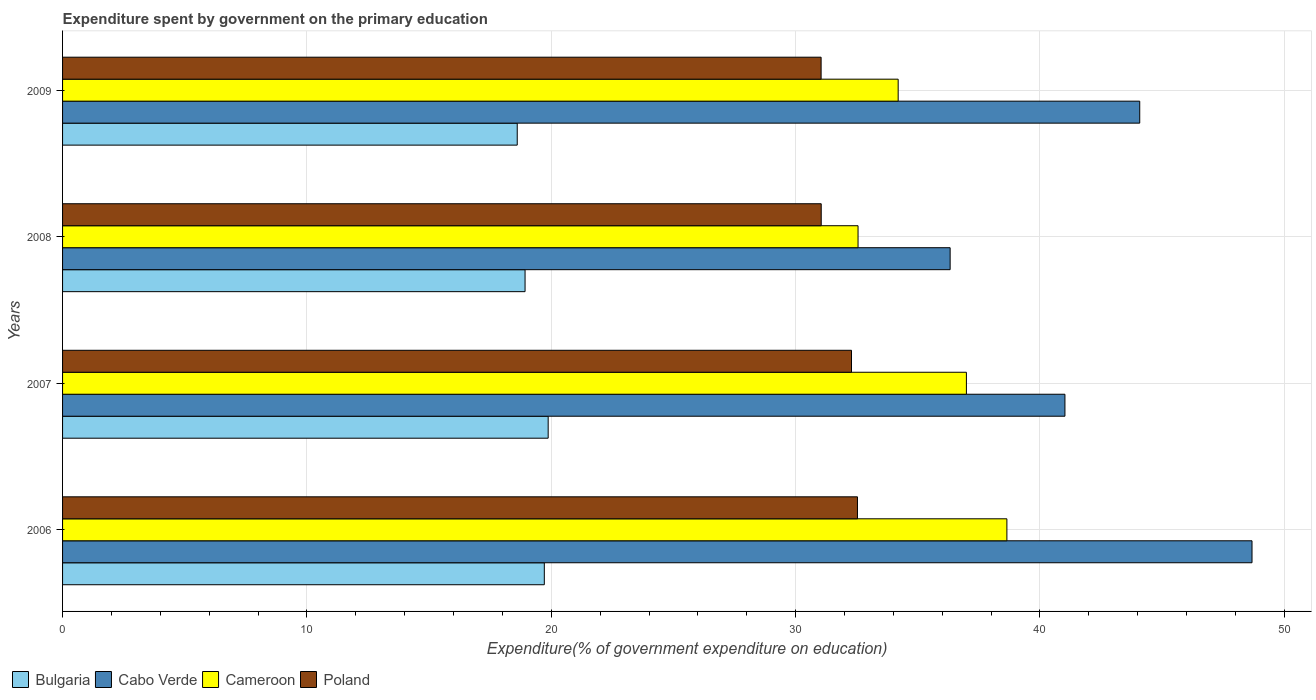Are the number of bars on each tick of the Y-axis equal?
Give a very brief answer. Yes. How many bars are there on the 2nd tick from the top?
Give a very brief answer. 4. In how many cases, is the number of bars for a given year not equal to the number of legend labels?
Your response must be concise. 0. What is the expenditure spent by government on the primary education in Cabo Verde in 2006?
Provide a succinct answer. 48.68. Across all years, what is the maximum expenditure spent by government on the primary education in Bulgaria?
Provide a succinct answer. 19.87. Across all years, what is the minimum expenditure spent by government on the primary education in Poland?
Provide a succinct answer. 31.04. In which year was the expenditure spent by government on the primary education in Cameroon maximum?
Keep it short and to the point. 2006. In which year was the expenditure spent by government on the primary education in Bulgaria minimum?
Make the answer very short. 2009. What is the total expenditure spent by government on the primary education in Cameroon in the graph?
Your answer should be very brief. 142.39. What is the difference between the expenditure spent by government on the primary education in Cabo Verde in 2008 and that in 2009?
Ensure brevity in your answer.  -7.76. What is the difference between the expenditure spent by government on the primary education in Cabo Verde in 2006 and the expenditure spent by government on the primary education in Poland in 2009?
Provide a succinct answer. 17.63. What is the average expenditure spent by government on the primary education in Cabo Verde per year?
Offer a very short reply. 42.53. In the year 2006, what is the difference between the expenditure spent by government on the primary education in Poland and expenditure spent by government on the primary education in Bulgaria?
Make the answer very short. 12.82. In how many years, is the expenditure spent by government on the primary education in Cabo Verde greater than 40 %?
Ensure brevity in your answer.  3. What is the ratio of the expenditure spent by government on the primary education in Cameroon in 2007 to that in 2009?
Provide a succinct answer. 1.08. Is the expenditure spent by government on the primary education in Poland in 2008 less than that in 2009?
Provide a short and direct response. No. Is the difference between the expenditure spent by government on the primary education in Poland in 2006 and 2008 greater than the difference between the expenditure spent by government on the primary education in Bulgaria in 2006 and 2008?
Offer a terse response. Yes. What is the difference between the highest and the second highest expenditure spent by government on the primary education in Bulgaria?
Your response must be concise. 0.16. What is the difference between the highest and the lowest expenditure spent by government on the primary education in Cameroon?
Offer a terse response. 6.09. Is it the case that in every year, the sum of the expenditure spent by government on the primary education in Bulgaria and expenditure spent by government on the primary education in Cameroon is greater than the expenditure spent by government on the primary education in Cabo Verde?
Give a very brief answer. Yes. How many years are there in the graph?
Ensure brevity in your answer.  4. What is the difference between two consecutive major ticks on the X-axis?
Your response must be concise. 10. Are the values on the major ticks of X-axis written in scientific E-notation?
Offer a terse response. No. Does the graph contain any zero values?
Give a very brief answer. No. Does the graph contain grids?
Keep it short and to the point. Yes. How many legend labels are there?
Your response must be concise. 4. What is the title of the graph?
Offer a terse response. Expenditure spent by government on the primary education. Does "Timor-Leste" appear as one of the legend labels in the graph?
Provide a short and direct response. No. What is the label or title of the X-axis?
Provide a succinct answer. Expenditure(% of government expenditure on education). What is the Expenditure(% of government expenditure on education) of Bulgaria in 2006?
Provide a short and direct response. 19.72. What is the Expenditure(% of government expenditure on education) of Cabo Verde in 2006?
Provide a short and direct response. 48.68. What is the Expenditure(% of government expenditure on education) in Cameroon in 2006?
Ensure brevity in your answer.  38.65. What is the Expenditure(% of government expenditure on education) in Poland in 2006?
Your answer should be very brief. 32.53. What is the Expenditure(% of government expenditure on education) in Bulgaria in 2007?
Offer a terse response. 19.87. What is the Expenditure(% of government expenditure on education) in Cabo Verde in 2007?
Make the answer very short. 41.02. What is the Expenditure(% of government expenditure on education) in Cameroon in 2007?
Provide a succinct answer. 36.99. What is the Expenditure(% of government expenditure on education) in Poland in 2007?
Your answer should be compact. 32.29. What is the Expenditure(% of government expenditure on education) of Bulgaria in 2008?
Provide a succinct answer. 18.93. What is the Expenditure(% of government expenditure on education) in Cabo Verde in 2008?
Keep it short and to the point. 36.32. What is the Expenditure(% of government expenditure on education) of Cameroon in 2008?
Give a very brief answer. 32.55. What is the Expenditure(% of government expenditure on education) of Poland in 2008?
Keep it short and to the point. 31.05. What is the Expenditure(% of government expenditure on education) in Bulgaria in 2009?
Keep it short and to the point. 18.61. What is the Expenditure(% of government expenditure on education) of Cabo Verde in 2009?
Ensure brevity in your answer.  44.08. What is the Expenditure(% of government expenditure on education) in Cameroon in 2009?
Make the answer very short. 34.2. What is the Expenditure(% of government expenditure on education) of Poland in 2009?
Provide a succinct answer. 31.04. Across all years, what is the maximum Expenditure(% of government expenditure on education) of Bulgaria?
Provide a short and direct response. 19.87. Across all years, what is the maximum Expenditure(% of government expenditure on education) of Cabo Verde?
Offer a terse response. 48.68. Across all years, what is the maximum Expenditure(% of government expenditure on education) of Cameroon?
Your answer should be compact. 38.65. Across all years, what is the maximum Expenditure(% of government expenditure on education) in Poland?
Your answer should be compact. 32.53. Across all years, what is the minimum Expenditure(% of government expenditure on education) of Bulgaria?
Your answer should be very brief. 18.61. Across all years, what is the minimum Expenditure(% of government expenditure on education) in Cabo Verde?
Offer a terse response. 36.32. Across all years, what is the minimum Expenditure(% of government expenditure on education) of Cameroon?
Offer a terse response. 32.55. Across all years, what is the minimum Expenditure(% of government expenditure on education) of Poland?
Offer a terse response. 31.04. What is the total Expenditure(% of government expenditure on education) of Bulgaria in the graph?
Your answer should be compact. 77.12. What is the total Expenditure(% of government expenditure on education) in Cabo Verde in the graph?
Provide a succinct answer. 170.11. What is the total Expenditure(% of government expenditure on education) of Cameroon in the graph?
Offer a very short reply. 142.39. What is the total Expenditure(% of government expenditure on education) of Poland in the graph?
Give a very brief answer. 126.91. What is the difference between the Expenditure(% of government expenditure on education) of Bulgaria in 2006 and that in 2007?
Offer a terse response. -0.16. What is the difference between the Expenditure(% of government expenditure on education) of Cabo Verde in 2006 and that in 2007?
Your answer should be compact. 7.66. What is the difference between the Expenditure(% of government expenditure on education) of Cameroon in 2006 and that in 2007?
Make the answer very short. 1.66. What is the difference between the Expenditure(% of government expenditure on education) of Poland in 2006 and that in 2007?
Offer a terse response. 0.24. What is the difference between the Expenditure(% of government expenditure on education) in Bulgaria in 2006 and that in 2008?
Your answer should be compact. 0.79. What is the difference between the Expenditure(% of government expenditure on education) in Cabo Verde in 2006 and that in 2008?
Make the answer very short. 12.35. What is the difference between the Expenditure(% of government expenditure on education) of Cameroon in 2006 and that in 2008?
Your answer should be compact. 6.09. What is the difference between the Expenditure(% of government expenditure on education) of Poland in 2006 and that in 2008?
Provide a short and direct response. 1.48. What is the difference between the Expenditure(% of government expenditure on education) in Bulgaria in 2006 and that in 2009?
Give a very brief answer. 1.11. What is the difference between the Expenditure(% of government expenditure on education) in Cabo Verde in 2006 and that in 2009?
Offer a terse response. 4.6. What is the difference between the Expenditure(% of government expenditure on education) of Cameroon in 2006 and that in 2009?
Make the answer very short. 4.45. What is the difference between the Expenditure(% of government expenditure on education) in Poland in 2006 and that in 2009?
Offer a very short reply. 1.49. What is the difference between the Expenditure(% of government expenditure on education) of Bulgaria in 2007 and that in 2008?
Give a very brief answer. 0.95. What is the difference between the Expenditure(% of government expenditure on education) of Cabo Verde in 2007 and that in 2008?
Your answer should be very brief. 4.7. What is the difference between the Expenditure(% of government expenditure on education) of Cameroon in 2007 and that in 2008?
Your answer should be compact. 4.43. What is the difference between the Expenditure(% of government expenditure on education) of Poland in 2007 and that in 2008?
Your answer should be compact. 1.24. What is the difference between the Expenditure(% of government expenditure on education) of Bulgaria in 2007 and that in 2009?
Provide a succinct answer. 1.27. What is the difference between the Expenditure(% of government expenditure on education) in Cabo Verde in 2007 and that in 2009?
Ensure brevity in your answer.  -3.06. What is the difference between the Expenditure(% of government expenditure on education) of Cameroon in 2007 and that in 2009?
Offer a terse response. 2.79. What is the difference between the Expenditure(% of government expenditure on education) of Poland in 2007 and that in 2009?
Your response must be concise. 1.24. What is the difference between the Expenditure(% of government expenditure on education) in Bulgaria in 2008 and that in 2009?
Your answer should be compact. 0.32. What is the difference between the Expenditure(% of government expenditure on education) in Cabo Verde in 2008 and that in 2009?
Your answer should be very brief. -7.76. What is the difference between the Expenditure(% of government expenditure on education) in Cameroon in 2008 and that in 2009?
Provide a succinct answer. -1.64. What is the difference between the Expenditure(% of government expenditure on education) of Poland in 2008 and that in 2009?
Make the answer very short. 0. What is the difference between the Expenditure(% of government expenditure on education) in Bulgaria in 2006 and the Expenditure(% of government expenditure on education) in Cabo Verde in 2007?
Your response must be concise. -21.31. What is the difference between the Expenditure(% of government expenditure on education) of Bulgaria in 2006 and the Expenditure(% of government expenditure on education) of Cameroon in 2007?
Provide a succinct answer. -17.27. What is the difference between the Expenditure(% of government expenditure on education) of Bulgaria in 2006 and the Expenditure(% of government expenditure on education) of Poland in 2007?
Give a very brief answer. -12.57. What is the difference between the Expenditure(% of government expenditure on education) in Cabo Verde in 2006 and the Expenditure(% of government expenditure on education) in Cameroon in 2007?
Ensure brevity in your answer.  11.69. What is the difference between the Expenditure(% of government expenditure on education) of Cabo Verde in 2006 and the Expenditure(% of government expenditure on education) of Poland in 2007?
Provide a succinct answer. 16.39. What is the difference between the Expenditure(% of government expenditure on education) in Cameroon in 2006 and the Expenditure(% of government expenditure on education) in Poland in 2007?
Make the answer very short. 6.36. What is the difference between the Expenditure(% of government expenditure on education) of Bulgaria in 2006 and the Expenditure(% of government expenditure on education) of Cabo Verde in 2008?
Ensure brevity in your answer.  -16.61. What is the difference between the Expenditure(% of government expenditure on education) of Bulgaria in 2006 and the Expenditure(% of government expenditure on education) of Cameroon in 2008?
Your answer should be compact. -12.84. What is the difference between the Expenditure(% of government expenditure on education) of Bulgaria in 2006 and the Expenditure(% of government expenditure on education) of Poland in 2008?
Keep it short and to the point. -11.33. What is the difference between the Expenditure(% of government expenditure on education) in Cabo Verde in 2006 and the Expenditure(% of government expenditure on education) in Cameroon in 2008?
Keep it short and to the point. 16.12. What is the difference between the Expenditure(% of government expenditure on education) of Cabo Verde in 2006 and the Expenditure(% of government expenditure on education) of Poland in 2008?
Your answer should be very brief. 17.63. What is the difference between the Expenditure(% of government expenditure on education) of Cameroon in 2006 and the Expenditure(% of government expenditure on education) of Poland in 2008?
Give a very brief answer. 7.6. What is the difference between the Expenditure(% of government expenditure on education) of Bulgaria in 2006 and the Expenditure(% of government expenditure on education) of Cabo Verde in 2009?
Provide a short and direct response. -24.37. What is the difference between the Expenditure(% of government expenditure on education) in Bulgaria in 2006 and the Expenditure(% of government expenditure on education) in Cameroon in 2009?
Ensure brevity in your answer.  -14.48. What is the difference between the Expenditure(% of government expenditure on education) of Bulgaria in 2006 and the Expenditure(% of government expenditure on education) of Poland in 2009?
Provide a short and direct response. -11.33. What is the difference between the Expenditure(% of government expenditure on education) in Cabo Verde in 2006 and the Expenditure(% of government expenditure on education) in Cameroon in 2009?
Keep it short and to the point. 14.48. What is the difference between the Expenditure(% of government expenditure on education) in Cabo Verde in 2006 and the Expenditure(% of government expenditure on education) in Poland in 2009?
Your response must be concise. 17.63. What is the difference between the Expenditure(% of government expenditure on education) in Cameroon in 2006 and the Expenditure(% of government expenditure on education) in Poland in 2009?
Ensure brevity in your answer.  7.6. What is the difference between the Expenditure(% of government expenditure on education) of Bulgaria in 2007 and the Expenditure(% of government expenditure on education) of Cabo Verde in 2008?
Provide a succinct answer. -16.45. What is the difference between the Expenditure(% of government expenditure on education) of Bulgaria in 2007 and the Expenditure(% of government expenditure on education) of Cameroon in 2008?
Your answer should be very brief. -12.68. What is the difference between the Expenditure(% of government expenditure on education) in Bulgaria in 2007 and the Expenditure(% of government expenditure on education) in Poland in 2008?
Provide a succinct answer. -11.17. What is the difference between the Expenditure(% of government expenditure on education) in Cabo Verde in 2007 and the Expenditure(% of government expenditure on education) in Cameroon in 2008?
Offer a very short reply. 8.47. What is the difference between the Expenditure(% of government expenditure on education) in Cabo Verde in 2007 and the Expenditure(% of government expenditure on education) in Poland in 2008?
Give a very brief answer. 9.97. What is the difference between the Expenditure(% of government expenditure on education) in Cameroon in 2007 and the Expenditure(% of government expenditure on education) in Poland in 2008?
Offer a terse response. 5.94. What is the difference between the Expenditure(% of government expenditure on education) in Bulgaria in 2007 and the Expenditure(% of government expenditure on education) in Cabo Verde in 2009?
Your response must be concise. -24.21. What is the difference between the Expenditure(% of government expenditure on education) in Bulgaria in 2007 and the Expenditure(% of government expenditure on education) in Cameroon in 2009?
Your response must be concise. -14.32. What is the difference between the Expenditure(% of government expenditure on education) in Bulgaria in 2007 and the Expenditure(% of government expenditure on education) in Poland in 2009?
Offer a very short reply. -11.17. What is the difference between the Expenditure(% of government expenditure on education) in Cabo Verde in 2007 and the Expenditure(% of government expenditure on education) in Cameroon in 2009?
Ensure brevity in your answer.  6.82. What is the difference between the Expenditure(% of government expenditure on education) in Cabo Verde in 2007 and the Expenditure(% of government expenditure on education) in Poland in 2009?
Make the answer very short. 9.98. What is the difference between the Expenditure(% of government expenditure on education) in Cameroon in 2007 and the Expenditure(% of government expenditure on education) in Poland in 2009?
Provide a succinct answer. 5.95. What is the difference between the Expenditure(% of government expenditure on education) in Bulgaria in 2008 and the Expenditure(% of government expenditure on education) in Cabo Verde in 2009?
Make the answer very short. -25.15. What is the difference between the Expenditure(% of government expenditure on education) of Bulgaria in 2008 and the Expenditure(% of government expenditure on education) of Cameroon in 2009?
Keep it short and to the point. -15.27. What is the difference between the Expenditure(% of government expenditure on education) in Bulgaria in 2008 and the Expenditure(% of government expenditure on education) in Poland in 2009?
Ensure brevity in your answer.  -12.12. What is the difference between the Expenditure(% of government expenditure on education) in Cabo Verde in 2008 and the Expenditure(% of government expenditure on education) in Cameroon in 2009?
Offer a very short reply. 2.13. What is the difference between the Expenditure(% of government expenditure on education) in Cabo Verde in 2008 and the Expenditure(% of government expenditure on education) in Poland in 2009?
Offer a very short reply. 5.28. What is the difference between the Expenditure(% of government expenditure on education) of Cameroon in 2008 and the Expenditure(% of government expenditure on education) of Poland in 2009?
Provide a succinct answer. 1.51. What is the average Expenditure(% of government expenditure on education) in Bulgaria per year?
Make the answer very short. 19.28. What is the average Expenditure(% of government expenditure on education) of Cabo Verde per year?
Give a very brief answer. 42.53. What is the average Expenditure(% of government expenditure on education) in Cameroon per year?
Give a very brief answer. 35.6. What is the average Expenditure(% of government expenditure on education) in Poland per year?
Ensure brevity in your answer.  31.73. In the year 2006, what is the difference between the Expenditure(% of government expenditure on education) in Bulgaria and Expenditure(% of government expenditure on education) in Cabo Verde?
Keep it short and to the point. -28.96. In the year 2006, what is the difference between the Expenditure(% of government expenditure on education) in Bulgaria and Expenditure(% of government expenditure on education) in Cameroon?
Your answer should be compact. -18.93. In the year 2006, what is the difference between the Expenditure(% of government expenditure on education) in Bulgaria and Expenditure(% of government expenditure on education) in Poland?
Offer a very short reply. -12.82. In the year 2006, what is the difference between the Expenditure(% of government expenditure on education) of Cabo Verde and Expenditure(% of government expenditure on education) of Cameroon?
Make the answer very short. 10.03. In the year 2006, what is the difference between the Expenditure(% of government expenditure on education) in Cabo Verde and Expenditure(% of government expenditure on education) in Poland?
Provide a short and direct response. 16.15. In the year 2006, what is the difference between the Expenditure(% of government expenditure on education) of Cameroon and Expenditure(% of government expenditure on education) of Poland?
Your response must be concise. 6.12. In the year 2007, what is the difference between the Expenditure(% of government expenditure on education) in Bulgaria and Expenditure(% of government expenditure on education) in Cabo Verde?
Your answer should be compact. -21.15. In the year 2007, what is the difference between the Expenditure(% of government expenditure on education) of Bulgaria and Expenditure(% of government expenditure on education) of Cameroon?
Your response must be concise. -17.12. In the year 2007, what is the difference between the Expenditure(% of government expenditure on education) in Bulgaria and Expenditure(% of government expenditure on education) in Poland?
Provide a short and direct response. -12.41. In the year 2007, what is the difference between the Expenditure(% of government expenditure on education) of Cabo Verde and Expenditure(% of government expenditure on education) of Cameroon?
Provide a short and direct response. 4.03. In the year 2007, what is the difference between the Expenditure(% of government expenditure on education) of Cabo Verde and Expenditure(% of government expenditure on education) of Poland?
Provide a succinct answer. 8.73. In the year 2007, what is the difference between the Expenditure(% of government expenditure on education) of Cameroon and Expenditure(% of government expenditure on education) of Poland?
Offer a very short reply. 4.7. In the year 2008, what is the difference between the Expenditure(% of government expenditure on education) in Bulgaria and Expenditure(% of government expenditure on education) in Cabo Verde?
Provide a succinct answer. -17.4. In the year 2008, what is the difference between the Expenditure(% of government expenditure on education) of Bulgaria and Expenditure(% of government expenditure on education) of Cameroon?
Your answer should be compact. -13.63. In the year 2008, what is the difference between the Expenditure(% of government expenditure on education) in Bulgaria and Expenditure(% of government expenditure on education) in Poland?
Keep it short and to the point. -12.12. In the year 2008, what is the difference between the Expenditure(% of government expenditure on education) of Cabo Verde and Expenditure(% of government expenditure on education) of Cameroon?
Your answer should be very brief. 3.77. In the year 2008, what is the difference between the Expenditure(% of government expenditure on education) of Cabo Verde and Expenditure(% of government expenditure on education) of Poland?
Provide a short and direct response. 5.28. In the year 2008, what is the difference between the Expenditure(% of government expenditure on education) in Cameroon and Expenditure(% of government expenditure on education) in Poland?
Your answer should be compact. 1.51. In the year 2009, what is the difference between the Expenditure(% of government expenditure on education) in Bulgaria and Expenditure(% of government expenditure on education) in Cabo Verde?
Provide a short and direct response. -25.48. In the year 2009, what is the difference between the Expenditure(% of government expenditure on education) in Bulgaria and Expenditure(% of government expenditure on education) in Cameroon?
Provide a short and direct response. -15.59. In the year 2009, what is the difference between the Expenditure(% of government expenditure on education) of Bulgaria and Expenditure(% of government expenditure on education) of Poland?
Provide a short and direct response. -12.44. In the year 2009, what is the difference between the Expenditure(% of government expenditure on education) in Cabo Verde and Expenditure(% of government expenditure on education) in Cameroon?
Make the answer very short. 9.89. In the year 2009, what is the difference between the Expenditure(% of government expenditure on education) of Cabo Verde and Expenditure(% of government expenditure on education) of Poland?
Provide a succinct answer. 13.04. In the year 2009, what is the difference between the Expenditure(% of government expenditure on education) of Cameroon and Expenditure(% of government expenditure on education) of Poland?
Your answer should be compact. 3.15. What is the ratio of the Expenditure(% of government expenditure on education) of Bulgaria in 2006 to that in 2007?
Offer a very short reply. 0.99. What is the ratio of the Expenditure(% of government expenditure on education) of Cabo Verde in 2006 to that in 2007?
Offer a very short reply. 1.19. What is the ratio of the Expenditure(% of government expenditure on education) of Cameroon in 2006 to that in 2007?
Give a very brief answer. 1.04. What is the ratio of the Expenditure(% of government expenditure on education) in Poland in 2006 to that in 2007?
Ensure brevity in your answer.  1.01. What is the ratio of the Expenditure(% of government expenditure on education) of Bulgaria in 2006 to that in 2008?
Offer a terse response. 1.04. What is the ratio of the Expenditure(% of government expenditure on education) of Cabo Verde in 2006 to that in 2008?
Make the answer very short. 1.34. What is the ratio of the Expenditure(% of government expenditure on education) in Cameroon in 2006 to that in 2008?
Your response must be concise. 1.19. What is the ratio of the Expenditure(% of government expenditure on education) in Poland in 2006 to that in 2008?
Offer a terse response. 1.05. What is the ratio of the Expenditure(% of government expenditure on education) of Bulgaria in 2006 to that in 2009?
Ensure brevity in your answer.  1.06. What is the ratio of the Expenditure(% of government expenditure on education) of Cabo Verde in 2006 to that in 2009?
Offer a terse response. 1.1. What is the ratio of the Expenditure(% of government expenditure on education) of Cameroon in 2006 to that in 2009?
Your answer should be very brief. 1.13. What is the ratio of the Expenditure(% of government expenditure on education) of Poland in 2006 to that in 2009?
Your response must be concise. 1.05. What is the ratio of the Expenditure(% of government expenditure on education) of Bulgaria in 2007 to that in 2008?
Your answer should be very brief. 1.05. What is the ratio of the Expenditure(% of government expenditure on education) in Cabo Verde in 2007 to that in 2008?
Your response must be concise. 1.13. What is the ratio of the Expenditure(% of government expenditure on education) of Cameroon in 2007 to that in 2008?
Your answer should be compact. 1.14. What is the ratio of the Expenditure(% of government expenditure on education) of Poland in 2007 to that in 2008?
Ensure brevity in your answer.  1.04. What is the ratio of the Expenditure(% of government expenditure on education) of Bulgaria in 2007 to that in 2009?
Provide a short and direct response. 1.07. What is the ratio of the Expenditure(% of government expenditure on education) of Cabo Verde in 2007 to that in 2009?
Ensure brevity in your answer.  0.93. What is the ratio of the Expenditure(% of government expenditure on education) of Cameroon in 2007 to that in 2009?
Offer a very short reply. 1.08. What is the ratio of the Expenditure(% of government expenditure on education) of Poland in 2007 to that in 2009?
Keep it short and to the point. 1.04. What is the ratio of the Expenditure(% of government expenditure on education) of Bulgaria in 2008 to that in 2009?
Your answer should be very brief. 1.02. What is the ratio of the Expenditure(% of government expenditure on education) of Cabo Verde in 2008 to that in 2009?
Give a very brief answer. 0.82. What is the ratio of the Expenditure(% of government expenditure on education) in Cameroon in 2008 to that in 2009?
Your answer should be very brief. 0.95. What is the ratio of the Expenditure(% of government expenditure on education) in Poland in 2008 to that in 2009?
Your answer should be compact. 1. What is the difference between the highest and the second highest Expenditure(% of government expenditure on education) in Bulgaria?
Make the answer very short. 0.16. What is the difference between the highest and the second highest Expenditure(% of government expenditure on education) of Cabo Verde?
Keep it short and to the point. 4.6. What is the difference between the highest and the second highest Expenditure(% of government expenditure on education) in Cameroon?
Your response must be concise. 1.66. What is the difference between the highest and the second highest Expenditure(% of government expenditure on education) in Poland?
Provide a short and direct response. 0.24. What is the difference between the highest and the lowest Expenditure(% of government expenditure on education) of Bulgaria?
Offer a terse response. 1.27. What is the difference between the highest and the lowest Expenditure(% of government expenditure on education) of Cabo Verde?
Make the answer very short. 12.35. What is the difference between the highest and the lowest Expenditure(% of government expenditure on education) in Cameroon?
Your response must be concise. 6.09. What is the difference between the highest and the lowest Expenditure(% of government expenditure on education) in Poland?
Make the answer very short. 1.49. 